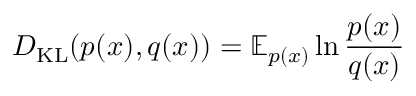<formula> <loc_0><loc_0><loc_500><loc_500>D _ { K L } ( p ( x ) , q ( x ) ) = \mathbb { E } _ { p ( x ) } \ln \frac { p ( x ) } { q ( x ) }</formula> 